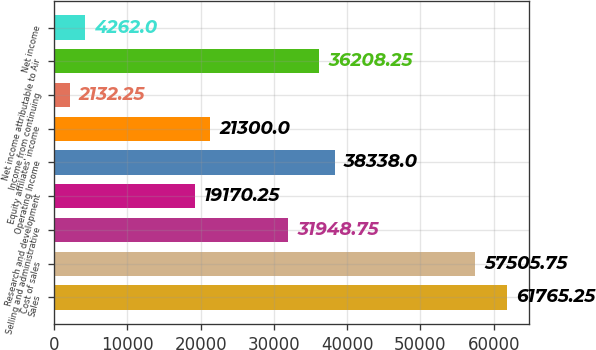<chart> <loc_0><loc_0><loc_500><loc_500><bar_chart><fcel>Sales<fcel>Cost of sales<fcel>Selling and administrative<fcel>Research and development<fcel>Operating Income<fcel>Equity affiliates' income<fcel>Income from continuing<fcel>Net income attributable to Air<fcel>Net income<nl><fcel>61765.2<fcel>57505.8<fcel>31948.8<fcel>19170.2<fcel>38338<fcel>21300<fcel>2132.25<fcel>36208.2<fcel>4262<nl></chart> 